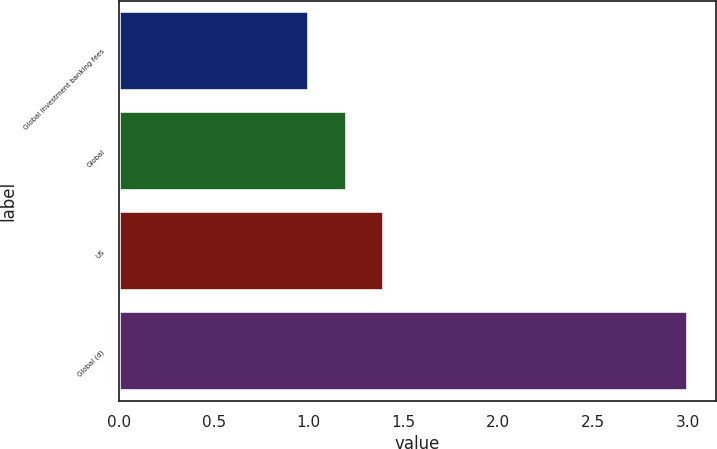Convert chart to OTSL. <chart><loc_0><loc_0><loc_500><loc_500><bar_chart><fcel>Global investment banking fees<fcel>Global<fcel>US<fcel>Global (d)<nl><fcel>1<fcel>1.2<fcel>1.4<fcel>3<nl></chart> 